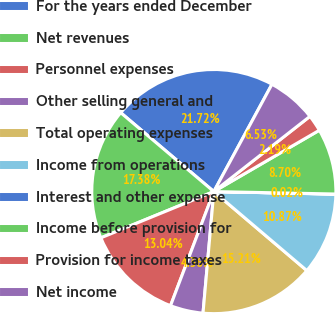Convert chart. <chart><loc_0><loc_0><loc_500><loc_500><pie_chart><fcel>For the years ended December<fcel>Net revenues<fcel>Personnel expenses<fcel>Other selling general and<fcel>Total operating expenses<fcel>Income from operations<fcel>Interest and other expense<fcel>Income before provision for<fcel>Provision for income taxes<fcel>Net income<nl><fcel>21.72%<fcel>17.38%<fcel>13.04%<fcel>4.36%<fcel>15.21%<fcel>10.87%<fcel>0.02%<fcel>8.7%<fcel>2.19%<fcel>6.53%<nl></chart> 